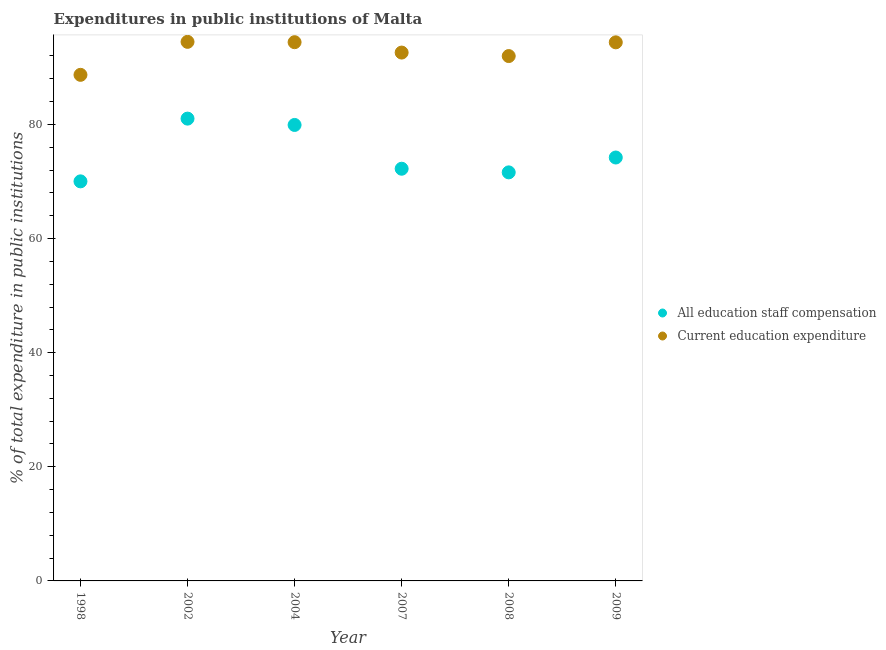How many different coloured dotlines are there?
Provide a succinct answer. 2. What is the expenditure in education in 2009?
Your response must be concise. 94.39. Across all years, what is the maximum expenditure in staff compensation?
Ensure brevity in your answer.  81.02. Across all years, what is the minimum expenditure in staff compensation?
Give a very brief answer. 70.03. In which year was the expenditure in staff compensation maximum?
Give a very brief answer. 2002. What is the total expenditure in staff compensation in the graph?
Give a very brief answer. 449.01. What is the difference between the expenditure in education in 2002 and that in 2004?
Offer a very short reply. 0.06. What is the difference between the expenditure in staff compensation in 2009 and the expenditure in education in 2008?
Make the answer very short. -17.78. What is the average expenditure in staff compensation per year?
Your answer should be very brief. 74.84. In the year 1998, what is the difference between the expenditure in staff compensation and expenditure in education?
Your answer should be very brief. -18.67. In how many years, is the expenditure in education greater than 64 %?
Your answer should be very brief. 6. What is the ratio of the expenditure in education in 2002 to that in 2009?
Your response must be concise. 1. Is the difference between the expenditure in education in 2007 and 2008 greater than the difference between the expenditure in staff compensation in 2007 and 2008?
Offer a very short reply. No. What is the difference between the highest and the second highest expenditure in staff compensation?
Your answer should be very brief. 1.11. What is the difference between the highest and the lowest expenditure in staff compensation?
Make the answer very short. 10.99. Is the sum of the expenditure in staff compensation in 2002 and 2004 greater than the maximum expenditure in education across all years?
Offer a terse response. Yes. Does the expenditure in staff compensation monotonically increase over the years?
Give a very brief answer. No. Is the expenditure in education strictly greater than the expenditure in staff compensation over the years?
Give a very brief answer. Yes. Is the expenditure in staff compensation strictly less than the expenditure in education over the years?
Provide a short and direct response. Yes. Does the graph contain any zero values?
Offer a very short reply. No. Does the graph contain grids?
Your answer should be compact. No. How are the legend labels stacked?
Your answer should be very brief. Vertical. What is the title of the graph?
Ensure brevity in your answer.  Expenditures in public institutions of Malta. Does "Non-resident workers" appear as one of the legend labels in the graph?
Ensure brevity in your answer.  No. What is the label or title of the Y-axis?
Offer a terse response. % of total expenditure in public institutions. What is the % of total expenditure in public institutions of All education staff compensation in 1998?
Make the answer very short. 70.03. What is the % of total expenditure in public institutions of Current education expenditure in 1998?
Make the answer very short. 88.7. What is the % of total expenditure in public institutions in All education staff compensation in 2002?
Keep it short and to the point. 81.02. What is the % of total expenditure in public institutions in Current education expenditure in 2002?
Your answer should be compact. 94.48. What is the % of total expenditure in public institutions of All education staff compensation in 2004?
Offer a terse response. 79.91. What is the % of total expenditure in public institutions of Current education expenditure in 2004?
Give a very brief answer. 94.42. What is the % of total expenditure in public institutions of All education staff compensation in 2007?
Your answer should be very brief. 72.24. What is the % of total expenditure in public institutions of Current education expenditure in 2007?
Your response must be concise. 92.6. What is the % of total expenditure in public institutions of All education staff compensation in 2008?
Provide a short and direct response. 71.6. What is the % of total expenditure in public institutions of Current education expenditure in 2008?
Your response must be concise. 91.99. What is the % of total expenditure in public institutions of All education staff compensation in 2009?
Your answer should be compact. 74.21. What is the % of total expenditure in public institutions in Current education expenditure in 2009?
Offer a terse response. 94.39. Across all years, what is the maximum % of total expenditure in public institutions in All education staff compensation?
Make the answer very short. 81.02. Across all years, what is the maximum % of total expenditure in public institutions in Current education expenditure?
Keep it short and to the point. 94.48. Across all years, what is the minimum % of total expenditure in public institutions in All education staff compensation?
Your response must be concise. 70.03. Across all years, what is the minimum % of total expenditure in public institutions in Current education expenditure?
Offer a very short reply. 88.7. What is the total % of total expenditure in public institutions in All education staff compensation in the graph?
Ensure brevity in your answer.  449.01. What is the total % of total expenditure in public institutions of Current education expenditure in the graph?
Offer a very short reply. 556.57. What is the difference between the % of total expenditure in public institutions in All education staff compensation in 1998 and that in 2002?
Give a very brief answer. -10.99. What is the difference between the % of total expenditure in public institutions in Current education expenditure in 1998 and that in 2002?
Your answer should be compact. -5.78. What is the difference between the % of total expenditure in public institutions in All education staff compensation in 1998 and that in 2004?
Offer a terse response. -9.89. What is the difference between the % of total expenditure in public institutions of Current education expenditure in 1998 and that in 2004?
Provide a succinct answer. -5.72. What is the difference between the % of total expenditure in public institutions of All education staff compensation in 1998 and that in 2007?
Provide a succinct answer. -2.21. What is the difference between the % of total expenditure in public institutions of Current education expenditure in 1998 and that in 2007?
Ensure brevity in your answer.  -3.9. What is the difference between the % of total expenditure in public institutions in All education staff compensation in 1998 and that in 2008?
Provide a short and direct response. -1.58. What is the difference between the % of total expenditure in public institutions in Current education expenditure in 1998 and that in 2008?
Your response must be concise. -3.29. What is the difference between the % of total expenditure in public institutions in All education staff compensation in 1998 and that in 2009?
Offer a terse response. -4.18. What is the difference between the % of total expenditure in public institutions in Current education expenditure in 1998 and that in 2009?
Provide a succinct answer. -5.7. What is the difference between the % of total expenditure in public institutions of All education staff compensation in 2002 and that in 2004?
Keep it short and to the point. 1.11. What is the difference between the % of total expenditure in public institutions in Current education expenditure in 2002 and that in 2004?
Offer a very short reply. 0.06. What is the difference between the % of total expenditure in public institutions in All education staff compensation in 2002 and that in 2007?
Offer a terse response. 8.78. What is the difference between the % of total expenditure in public institutions in Current education expenditure in 2002 and that in 2007?
Provide a succinct answer. 1.88. What is the difference between the % of total expenditure in public institutions of All education staff compensation in 2002 and that in 2008?
Your answer should be compact. 9.42. What is the difference between the % of total expenditure in public institutions of Current education expenditure in 2002 and that in 2008?
Keep it short and to the point. 2.49. What is the difference between the % of total expenditure in public institutions in All education staff compensation in 2002 and that in 2009?
Your answer should be compact. 6.82. What is the difference between the % of total expenditure in public institutions of Current education expenditure in 2002 and that in 2009?
Provide a short and direct response. 0.09. What is the difference between the % of total expenditure in public institutions in All education staff compensation in 2004 and that in 2007?
Your answer should be very brief. 7.67. What is the difference between the % of total expenditure in public institutions in Current education expenditure in 2004 and that in 2007?
Your answer should be compact. 1.82. What is the difference between the % of total expenditure in public institutions of All education staff compensation in 2004 and that in 2008?
Offer a very short reply. 8.31. What is the difference between the % of total expenditure in public institutions of Current education expenditure in 2004 and that in 2008?
Provide a succinct answer. 2.43. What is the difference between the % of total expenditure in public institutions of All education staff compensation in 2004 and that in 2009?
Keep it short and to the point. 5.71. What is the difference between the % of total expenditure in public institutions in Current education expenditure in 2004 and that in 2009?
Your response must be concise. 0.03. What is the difference between the % of total expenditure in public institutions in All education staff compensation in 2007 and that in 2008?
Ensure brevity in your answer.  0.64. What is the difference between the % of total expenditure in public institutions in Current education expenditure in 2007 and that in 2008?
Make the answer very short. 0.61. What is the difference between the % of total expenditure in public institutions in All education staff compensation in 2007 and that in 2009?
Provide a succinct answer. -1.97. What is the difference between the % of total expenditure in public institutions in Current education expenditure in 2007 and that in 2009?
Offer a very short reply. -1.79. What is the difference between the % of total expenditure in public institutions of All education staff compensation in 2008 and that in 2009?
Ensure brevity in your answer.  -2.6. What is the difference between the % of total expenditure in public institutions of Current education expenditure in 2008 and that in 2009?
Keep it short and to the point. -2.41. What is the difference between the % of total expenditure in public institutions of All education staff compensation in 1998 and the % of total expenditure in public institutions of Current education expenditure in 2002?
Provide a short and direct response. -24.45. What is the difference between the % of total expenditure in public institutions of All education staff compensation in 1998 and the % of total expenditure in public institutions of Current education expenditure in 2004?
Give a very brief answer. -24.39. What is the difference between the % of total expenditure in public institutions in All education staff compensation in 1998 and the % of total expenditure in public institutions in Current education expenditure in 2007?
Provide a succinct answer. -22.57. What is the difference between the % of total expenditure in public institutions of All education staff compensation in 1998 and the % of total expenditure in public institutions of Current education expenditure in 2008?
Ensure brevity in your answer.  -21.96. What is the difference between the % of total expenditure in public institutions in All education staff compensation in 1998 and the % of total expenditure in public institutions in Current education expenditure in 2009?
Give a very brief answer. -24.36. What is the difference between the % of total expenditure in public institutions in All education staff compensation in 2002 and the % of total expenditure in public institutions in Current education expenditure in 2004?
Give a very brief answer. -13.4. What is the difference between the % of total expenditure in public institutions in All education staff compensation in 2002 and the % of total expenditure in public institutions in Current education expenditure in 2007?
Your answer should be very brief. -11.58. What is the difference between the % of total expenditure in public institutions of All education staff compensation in 2002 and the % of total expenditure in public institutions of Current education expenditure in 2008?
Provide a short and direct response. -10.96. What is the difference between the % of total expenditure in public institutions in All education staff compensation in 2002 and the % of total expenditure in public institutions in Current education expenditure in 2009?
Your answer should be very brief. -13.37. What is the difference between the % of total expenditure in public institutions of All education staff compensation in 2004 and the % of total expenditure in public institutions of Current education expenditure in 2007?
Your answer should be very brief. -12.69. What is the difference between the % of total expenditure in public institutions of All education staff compensation in 2004 and the % of total expenditure in public institutions of Current education expenditure in 2008?
Your answer should be very brief. -12.07. What is the difference between the % of total expenditure in public institutions of All education staff compensation in 2004 and the % of total expenditure in public institutions of Current education expenditure in 2009?
Your answer should be compact. -14.48. What is the difference between the % of total expenditure in public institutions of All education staff compensation in 2007 and the % of total expenditure in public institutions of Current education expenditure in 2008?
Your answer should be compact. -19.75. What is the difference between the % of total expenditure in public institutions in All education staff compensation in 2007 and the % of total expenditure in public institutions in Current education expenditure in 2009?
Make the answer very short. -22.15. What is the difference between the % of total expenditure in public institutions in All education staff compensation in 2008 and the % of total expenditure in public institutions in Current education expenditure in 2009?
Provide a succinct answer. -22.79. What is the average % of total expenditure in public institutions of All education staff compensation per year?
Offer a very short reply. 74.84. What is the average % of total expenditure in public institutions of Current education expenditure per year?
Provide a short and direct response. 92.76. In the year 1998, what is the difference between the % of total expenditure in public institutions of All education staff compensation and % of total expenditure in public institutions of Current education expenditure?
Offer a very short reply. -18.67. In the year 2002, what is the difference between the % of total expenditure in public institutions of All education staff compensation and % of total expenditure in public institutions of Current education expenditure?
Ensure brevity in your answer.  -13.46. In the year 2004, what is the difference between the % of total expenditure in public institutions in All education staff compensation and % of total expenditure in public institutions in Current education expenditure?
Your response must be concise. -14.51. In the year 2007, what is the difference between the % of total expenditure in public institutions of All education staff compensation and % of total expenditure in public institutions of Current education expenditure?
Offer a very short reply. -20.36. In the year 2008, what is the difference between the % of total expenditure in public institutions in All education staff compensation and % of total expenditure in public institutions in Current education expenditure?
Provide a succinct answer. -20.38. In the year 2009, what is the difference between the % of total expenditure in public institutions in All education staff compensation and % of total expenditure in public institutions in Current education expenditure?
Offer a terse response. -20.19. What is the ratio of the % of total expenditure in public institutions in All education staff compensation in 1998 to that in 2002?
Provide a succinct answer. 0.86. What is the ratio of the % of total expenditure in public institutions of Current education expenditure in 1998 to that in 2002?
Offer a very short reply. 0.94. What is the ratio of the % of total expenditure in public institutions of All education staff compensation in 1998 to that in 2004?
Provide a short and direct response. 0.88. What is the ratio of the % of total expenditure in public institutions of Current education expenditure in 1998 to that in 2004?
Provide a short and direct response. 0.94. What is the ratio of the % of total expenditure in public institutions in All education staff compensation in 1998 to that in 2007?
Your answer should be compact. 0.97. What is the ratio of the % of total expenditure in public institutions in Current education expenditure in 1998 to that in 2007?
Provide a succinct answer. 0.96. What is the ratio of the % of total expenditure in public institutions in Current education expenditure in 1998 to that in 2008?
Keep it short and to the point. 0.96. What is the ratio of the % of total expenditure in public institutions of All education staff compensation in 1998 to that in 2009?
Provide a short and direct response. 0.94. What is the ratio of the % of total expenditure in public institutions of Current education expenditure in 1998 to that in 2009?
Provide a succinct answer. 0.94. What is the ratio of the % of total expenditure in public institutions in All education staff compensation in 2002 to that in 2004?
Provide a short and direct response. 1.01. What is the ratio of the % of total expenditure in public institutions of Current education expenditure in 2002 to that in 2004?
Keep it short and to the point. 1. What is the ratio of the % of total expenditure in public institutions in All education staff compensation in 2002 to that in 2007?
Your response must be concise. 1.12. What is the ratio of the % of total expenditure in public institutions in Current education expenditure in 2002 to that in 2007?
Your answer should be compact. 1.02. What is the ratio of the % of total expenditure in public institutions of All education staff compensation in 2002 to that in 2008?
Offer a terse response. 1.13. What is the ratio of the % of total expenditure in public institutions in Current education expenditure in 2002 to that in 2008?
Offer a very short reply. 1.03. What is the ratio of the % of total expenditure in public institutions in All education staff compensation in 2002 to that in 2009?
Give a very brief answer. 1.09. What is the ratio of the % of total expenditure in public institutions of All education staff compensation in 2004 to that in 2007?
Provide a short and direct response. 1.11. What is the ratio of the % of total expenditure in public institutions in Current education expenditure in 2004 to that in 2007?
Make the answer very short. 1.02. What is the ratio of the % of total expenditure in public institutions of All education staff compensation in 2004 to that in 2008?
Offer a terse response. 1.12. What is the ratio of the % of total expenditure in public institutions of Current education expenditure in 2004 to that in 2008?
Offer a very short reply. 1.03. What is the ratio of the % of total expenditure in public institutions of All education staff compensation in 2004 to that in 2009?
Offer a very short reply. 1.08. What is the ratio of the % of total expenditure in public institutions in Current education expenditure in 2004 to that in 2009?
Offer a terse response. 1. What is the ratio of the % of total expenditure in public institutions in All education staff compensation in 2007 to that in 2008?
Provide a succinct answer. 1.01. What is the ratio of the % of total expenditure in public institutions of All education staff compensation in 2007 to that in 2009?
Keep it short and to the point. 0.97. What is the ratio of the % of total expenditure in public institutions in Current education expenditure in 2007 to that in 2009?
Offer a very short reply. 0.98. What is the ratio of the % of total expenditure in public institutions of All education staff compensation in 2008 to that in 2009?
Your response must be concise. 0.96. What is the ratio of the % of total expenditure in public institutions of Current education expenditure in 2008 to that in 2009?
Your answer should be compact. 0.97. What is the difference between the highest and the second highest % of total expenditure in public institutions in All education staff compensation?
Offer a very short reply. 1.11. What is the difference between the highest and the second highest % of total expenditure in public institutions in Current education expenditure?
Ensure brevity in your answer.  0.06. What is the difference between the highest and the lowest % of total expenditure in public institutions in All education staff compensation?
Your answer should be very brief. 10.99. What is the difference between the highest and the lowest % of total expenditure in public institutions in Current education expenditure?
Offer a very short reply. 5.78. 